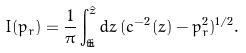Convert formula to latex. <formula><loc_0><loc_0><loc_500><loc_500>I ( p _ { r } ) = \frac { 1 } { \pi } \int _ { \check { z } } ^ { \hat { z } } d z \, ( c ^ { - 2 } ( z ) - p _ { r } ^ { 2 } ) ^ { 1 / 2 } .</formula> 